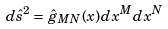Convert formula to latex. <formula><loc_0><loc_0><loc_500><loc_500>d { \hat { s } } ^ { 2 } = { \hat { g } } _ { M N } ( x ) d x ^ { M } d x ^ { N }</formula> 